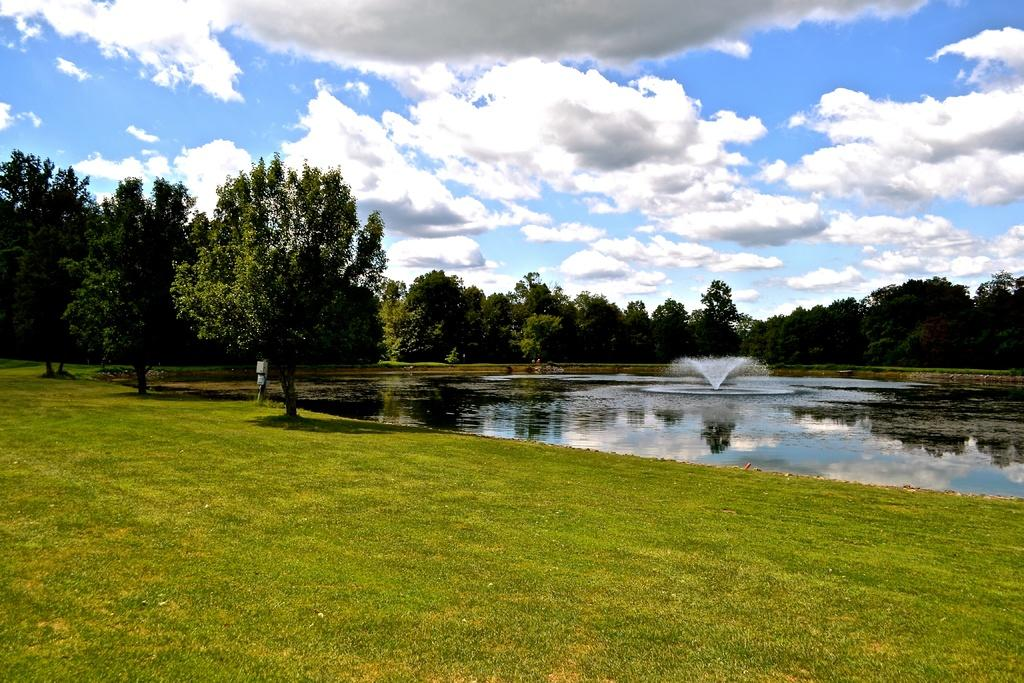What is the main feature in the center of the image? There is a fountain in the center of the image. What type of surface is at the bottom of the image? There is grass on the surface at the bottom of the image. What can be seen in the background of the image? There are trees and the sky visible in the background of the image. How many stars can be seen on the fountain in the image? There are no stars visible on the fountain in the image. What type of grape is growing on the trees in the background? There are no grapes present in the image; the trees in the background are not specified as fruit-bearing trees. 